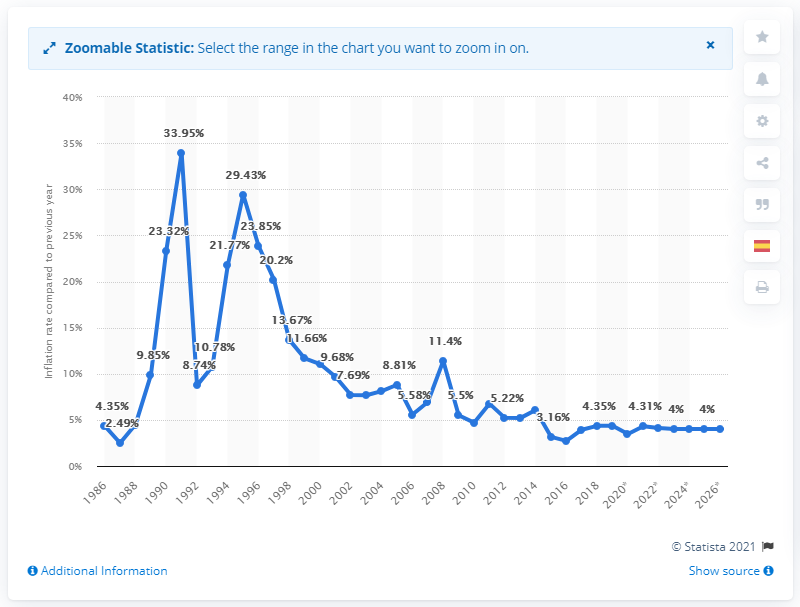Indicate a few pertinent items in this graphic. In 1986, the average inflation rate in Honduras was X. 